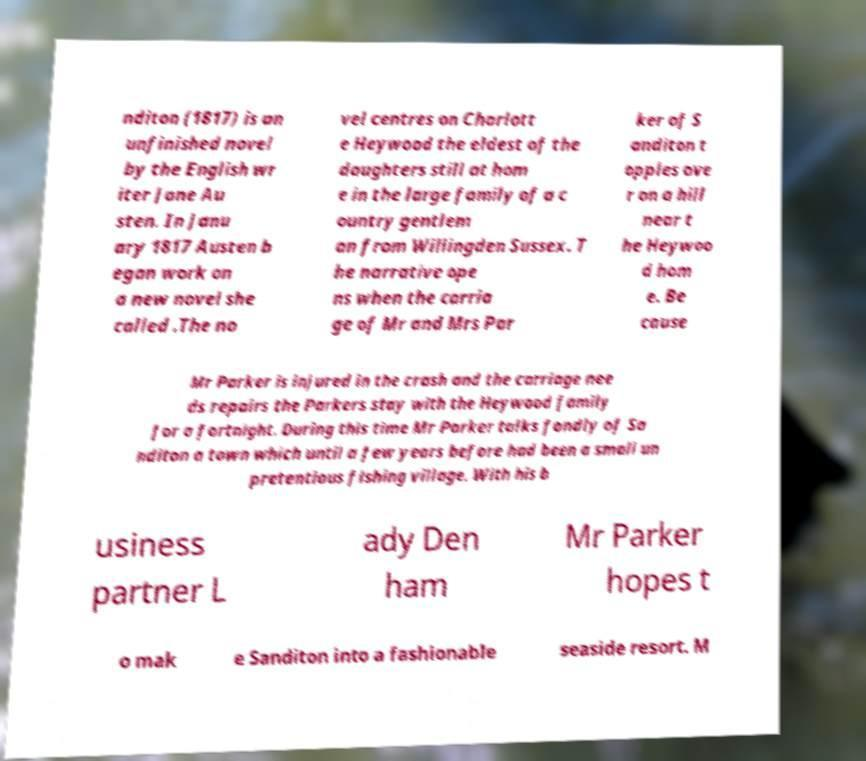Could you extract and type out the text from this image? nditon (1817) is an unfinished novel by the English wr iter Jane Au sten. In Janu ary 1817 Austen b egan work on a new novel she called .The no vel centres on Charlott e Heywood the eldest of the daughters still at hom e in the large family of a c ountry gentlem an from Willingden Sussex. T he narrative ope ns when the carria ge of Mr and Mrs Par ker of S anditon t opples ove r on a hill near t he Heywoo d hom e. Be cause Mr Parker is injured in the crash and the carriage nee ds repairs the Parkers stay with the Heywood family for a fortnight. During this time Mr Parker talks fondly of Sa nditon a town which until a few years before had been a small un pretentious fishing village. With his b usiness partner L ady Den ham Mr Parker hopes t o mak e Sanditon into a fashionable seaside resort. M 